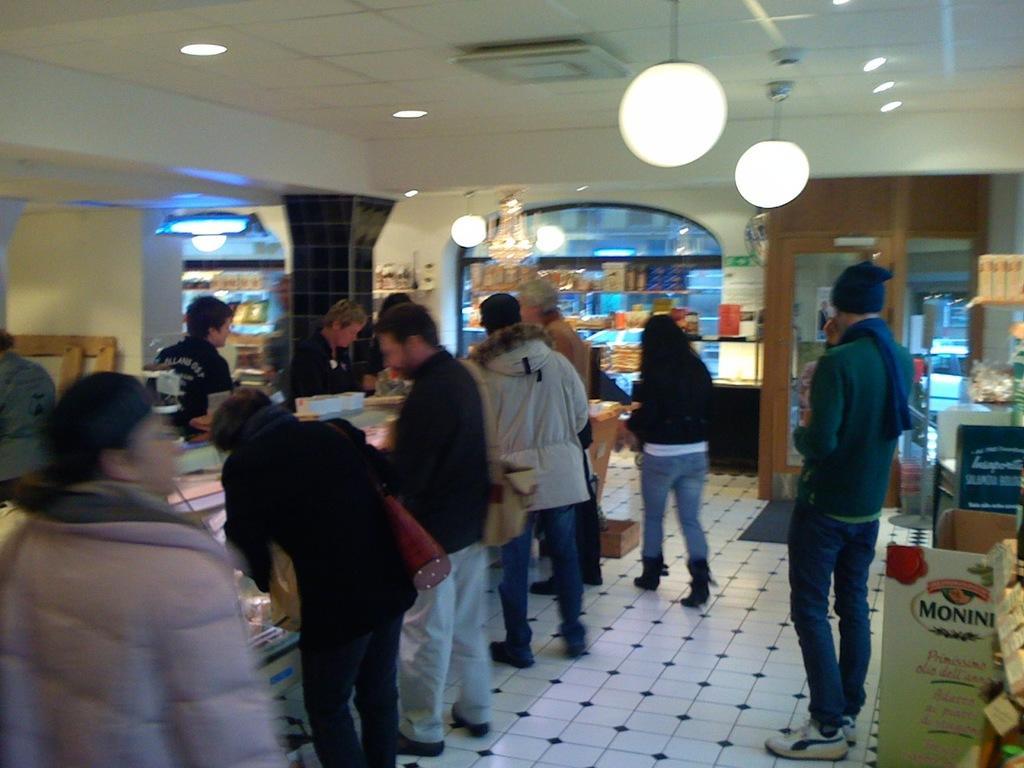In one or two sentences, can you explain what this image depicts? In this image I can see number of persons wearing jackets are standing on the surface which is white in color and in the background I can see few other persons standing, the ceiling, few lamps, few lights to the ceiling, the brown colored door and few other objects. 